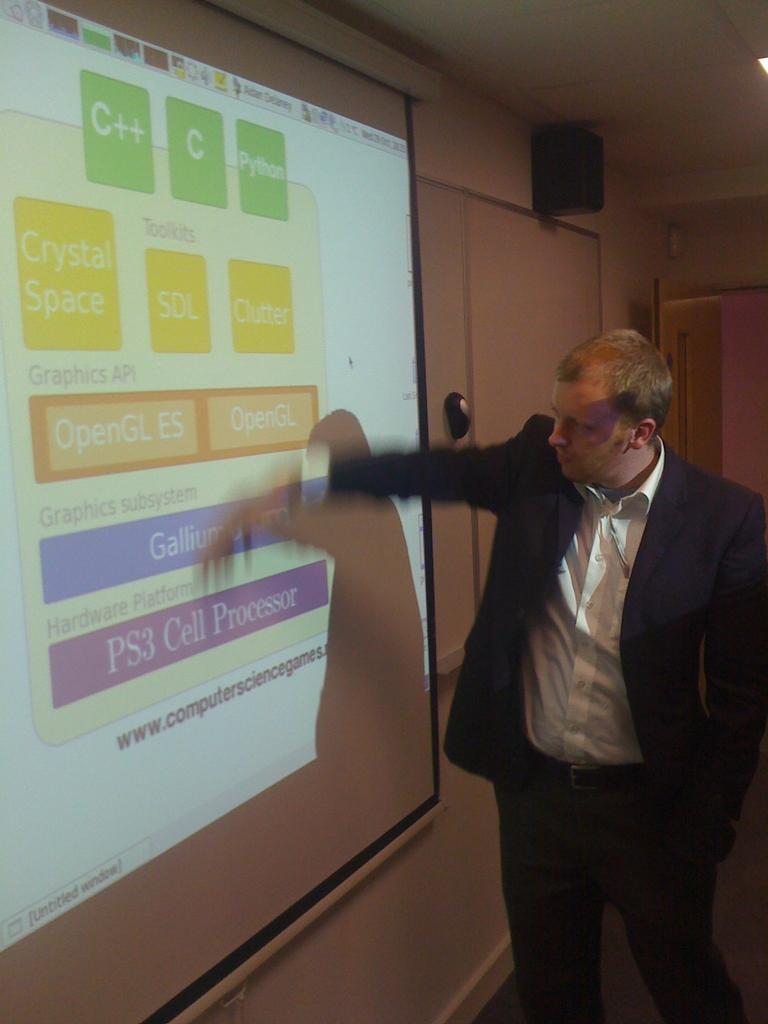Provide a one-sentence caption for the provided image. A man wearing a sportcoat is giving a presentation about PS3 Cell processors. 